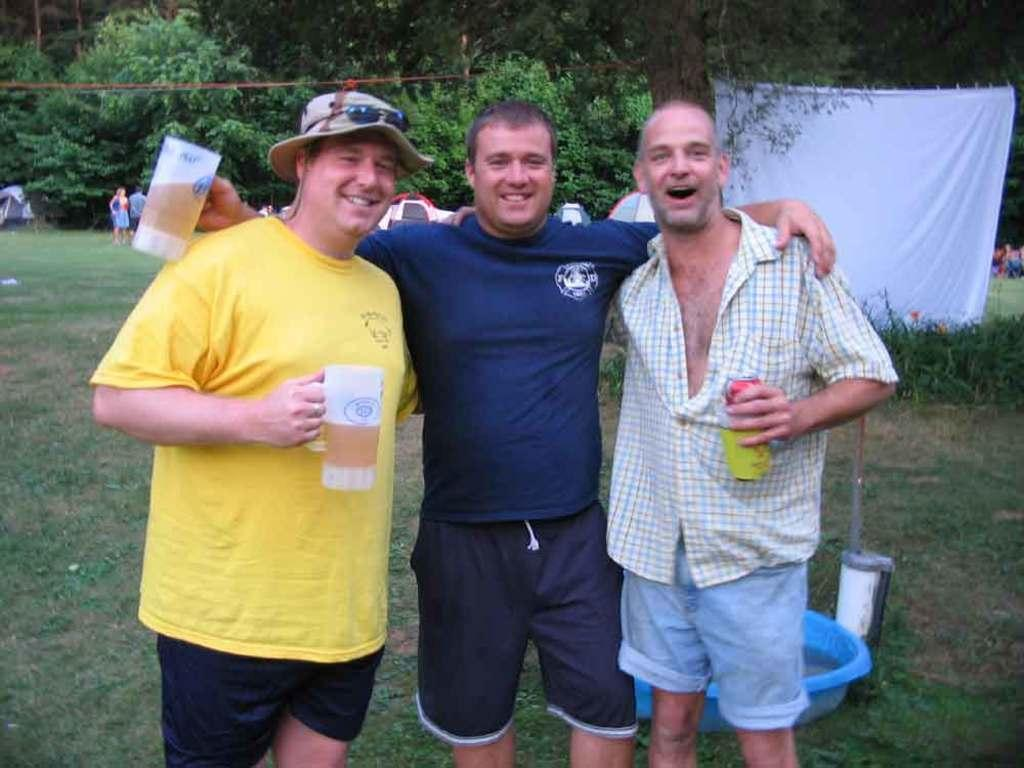How many people are present in the image? There are three people in the image. What can be seen on the right side of the image? There is a white cloth on the right side of the image. What is visible in the background of the image? There are trees in the background of the image. What type of linen is the queen using to cover her throne in the image? There is no queen or throne present in the image, and therefore no linen can be associated with them. 